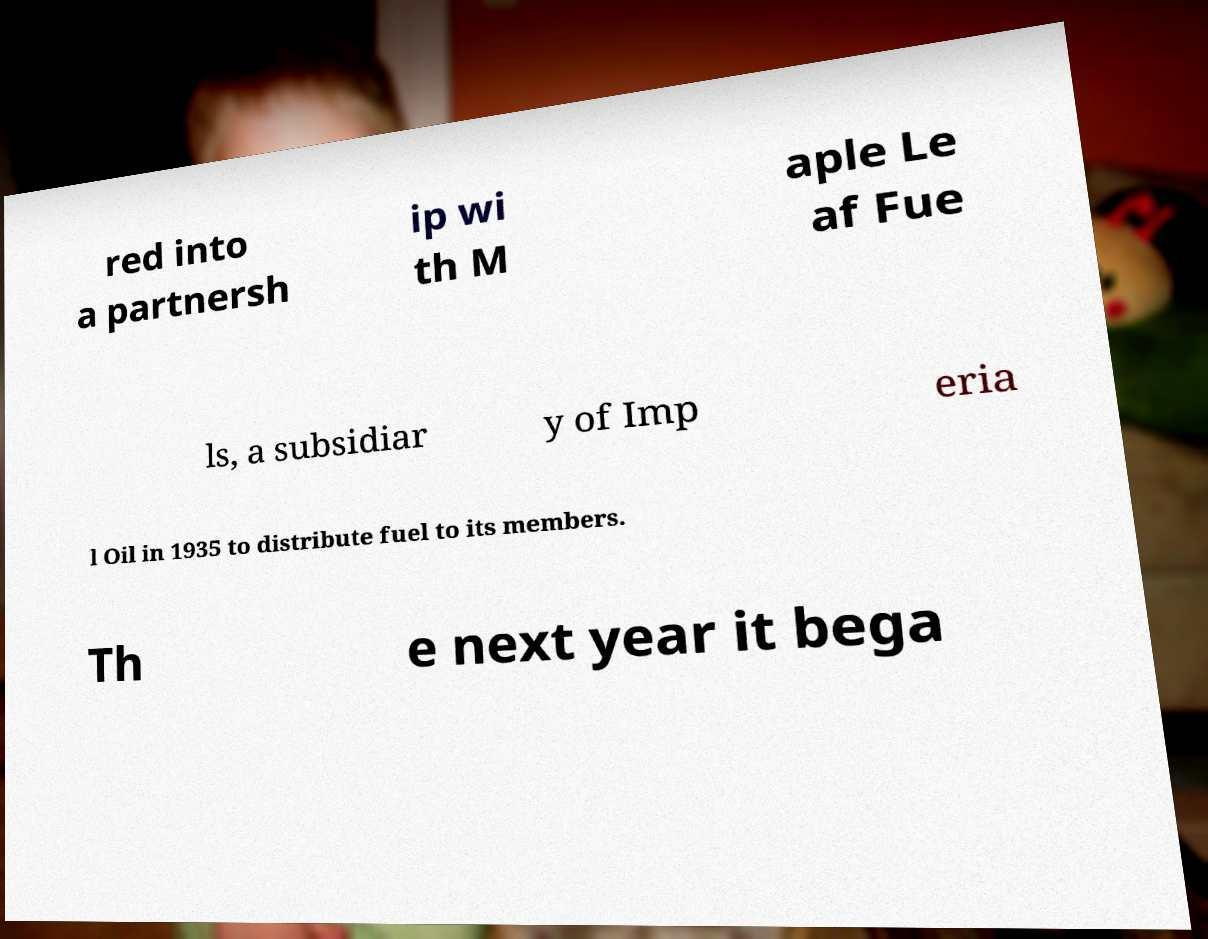Can you read and provide the text displayed in the image?This photo seems to have some interesting text. Can you extract and type it out for me? red into a partnersh ip wi th M aple Le af Fue ls, a subsidiar y of Imp eria l Oil in 1935 to distribute fuel to its members. Th e next year it bega 